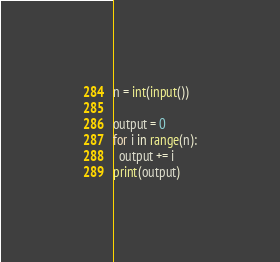Convert code to text. <code><loc_0><loc_0><loc_500><loc_500><_Python_>n = int(input())

output = 0
for i in range(n):
  output += i
print(output)</code> 